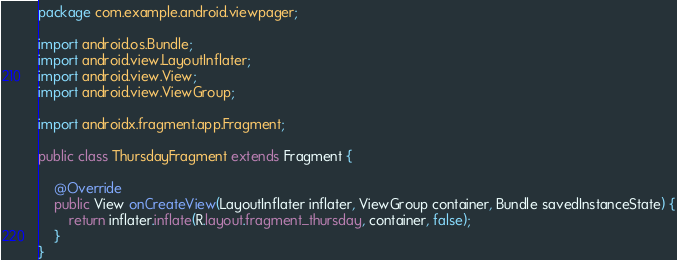<code> <loc_0><loc_0><loc_500><loc_500><_Java_>package com.example.android.viewpager;

import android.os.Bundle;
import android.view.LayoutInflater;
import android.view.View;
import android.view.ViewGroup;

import androidx.fragment.app.Fragment;

public class ThursdayFragment extends Fragment {

    @Override
    public View onCreateView(LayoutInflater inflater, ViewGroup container, Bundle savedInstanceState) {
        return inflater.inflate(R.layout.fragment_thursday, container, false);
    }
}
</code> 